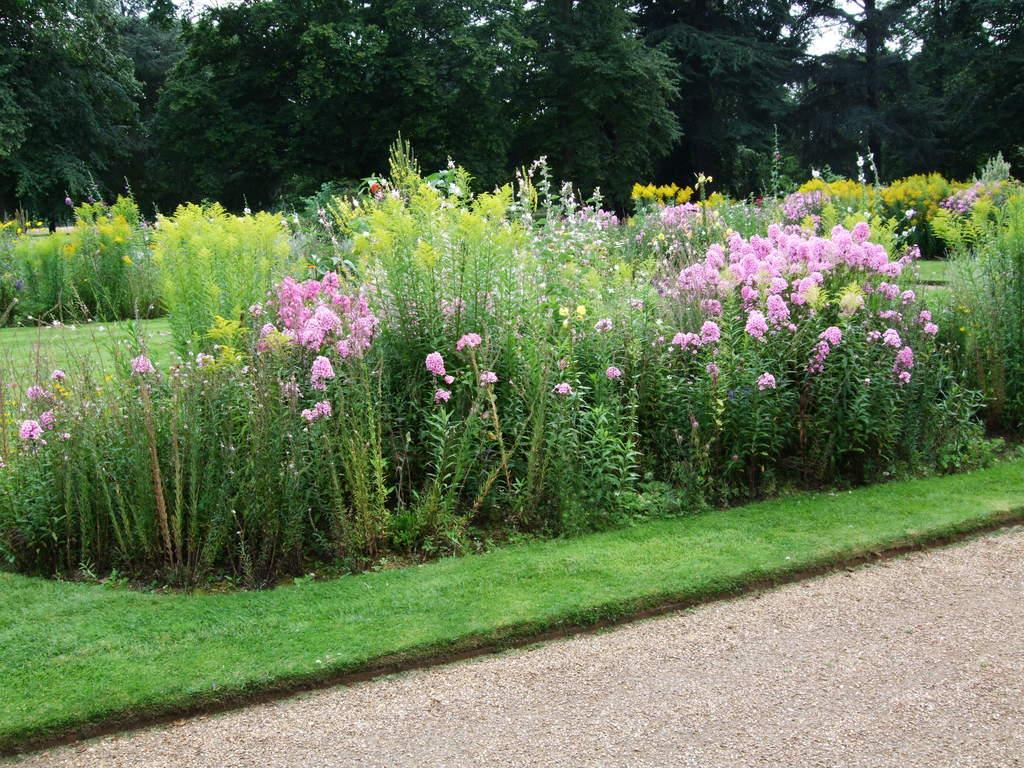What type of terrain is visible in the image? There is a land visible in the image. What can be seen in the background of the image? There is grassland, flower plants, and trees visible in the background of the image. What key is used to unlock the door in the image? There is no door or key present in the image; it features a land with grassland, flower plants, and trees in the background. 